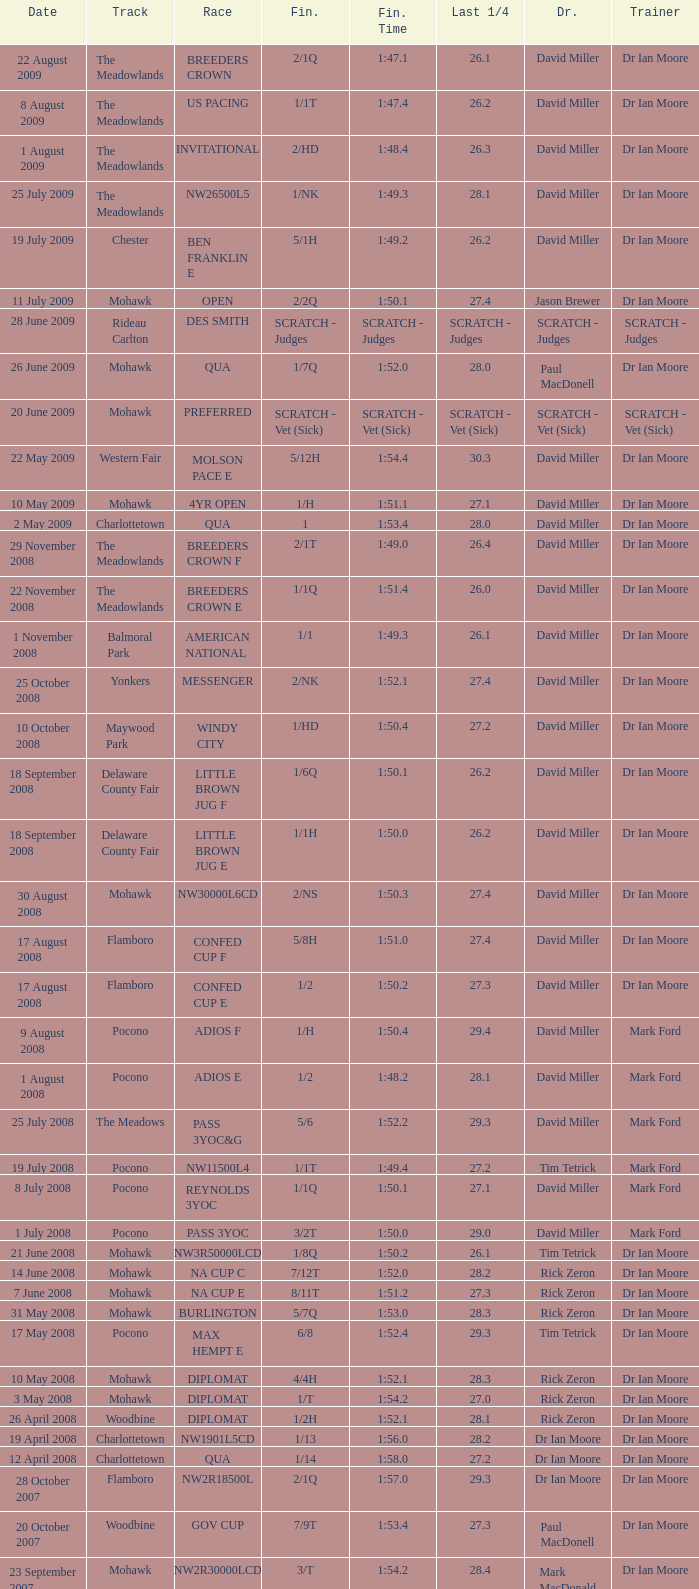1? 29.2. 